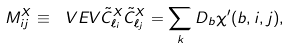Convert formula to latex. <formula><loc_0><loc_0><loc_500><loc_500>M ^ { X } _ { i j } \equiv \ V E V { \tilde { C } _ { \ell _ { i } } ^ { X } \tilde { C } _ { \ell _ { j } } ^ { X } } = \sum _ { k } D _ { b } \chi ^ { \prime } ( b , i , j ) ,</formula> 